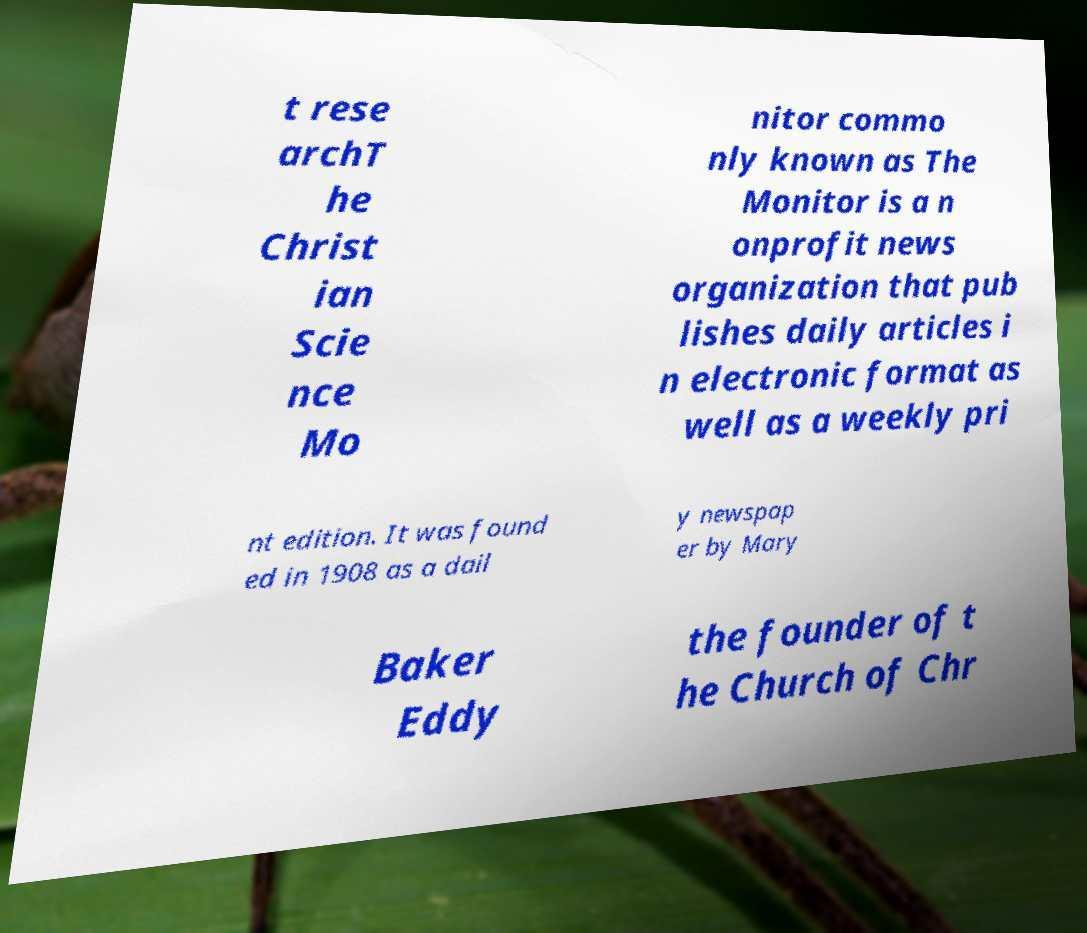Could you assist in decoding the text presented in this image and type it out clearly? t rese archT he Christ ian Scie nce Mo nitor commo nly known as The Monitor is a n onprofit news organization that pub lishes daily articles i n electronic format as well as a weekly pri nt edition. It was found ed in 1908 as a dail y newspap er by Mary Baker Eddy the founder of t he Church of Chr 